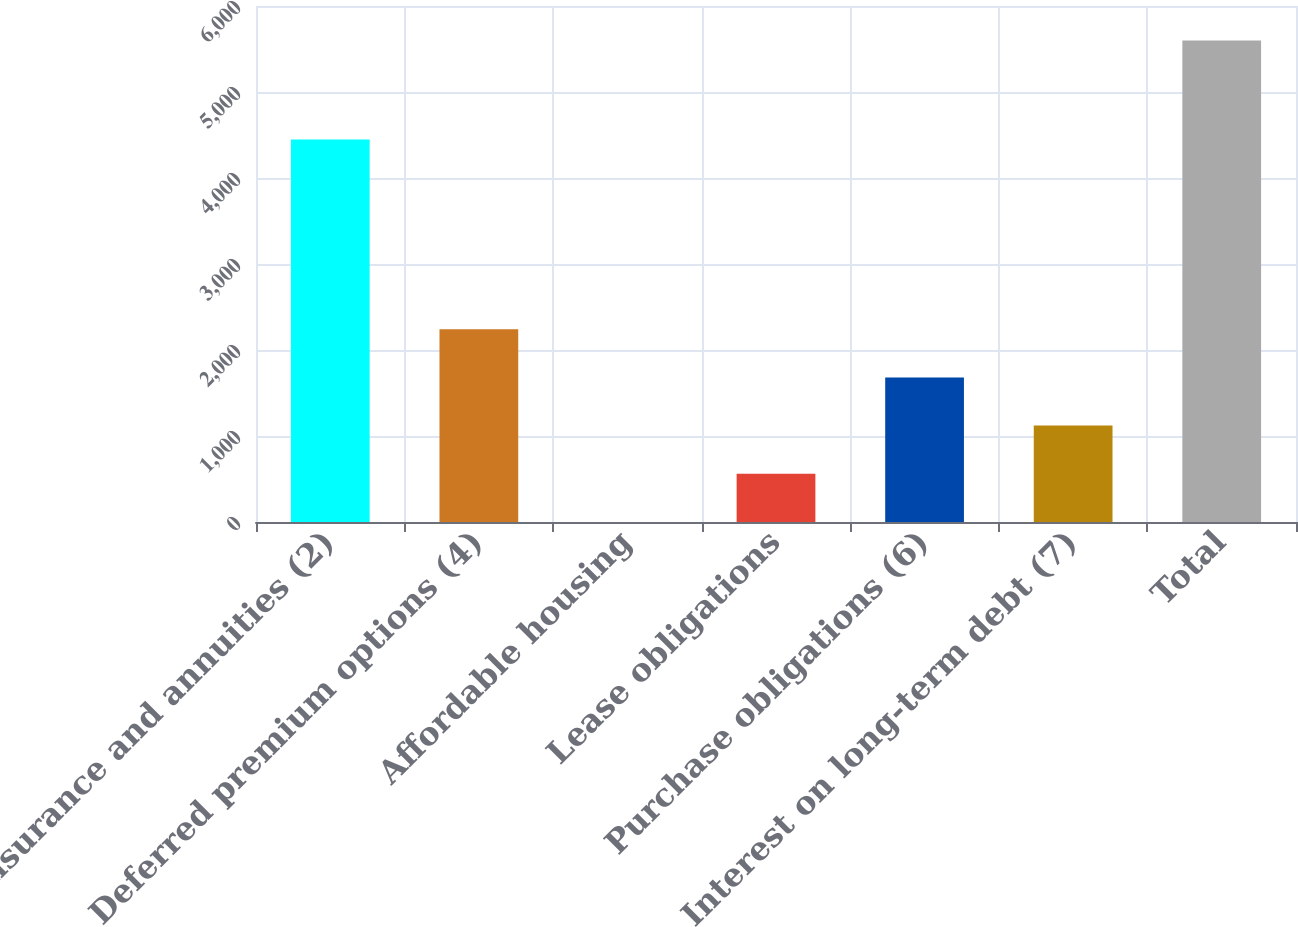Convert chart. <chart><loc_0><loc_0><loc_500><loc_500><bar_chart><fcel>Insurance and annuities (2)<fcel>Deferred premium options (4)<fcel>Affordable housing<fcel>Lease obligations<fcel>Purchase obligations (6)<fcel>Interest on long-term debt (7)<fcel>Total<nl><fcel>4447<fcel>2240.6<fcel>1<fcel>560.9<fcel>1680.7<fcel>1120.8<fcel>5600<nl></chart> 